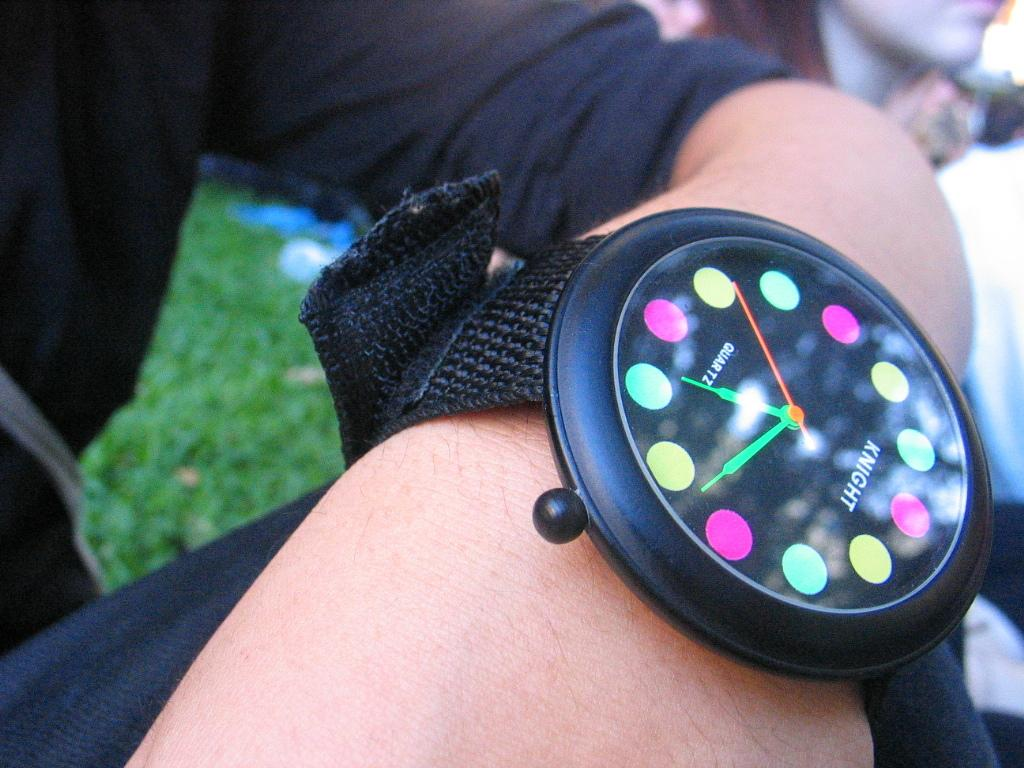<image>
Give a short and clear explanation of the subsequent image. A colorful watch says Knight on the face. 